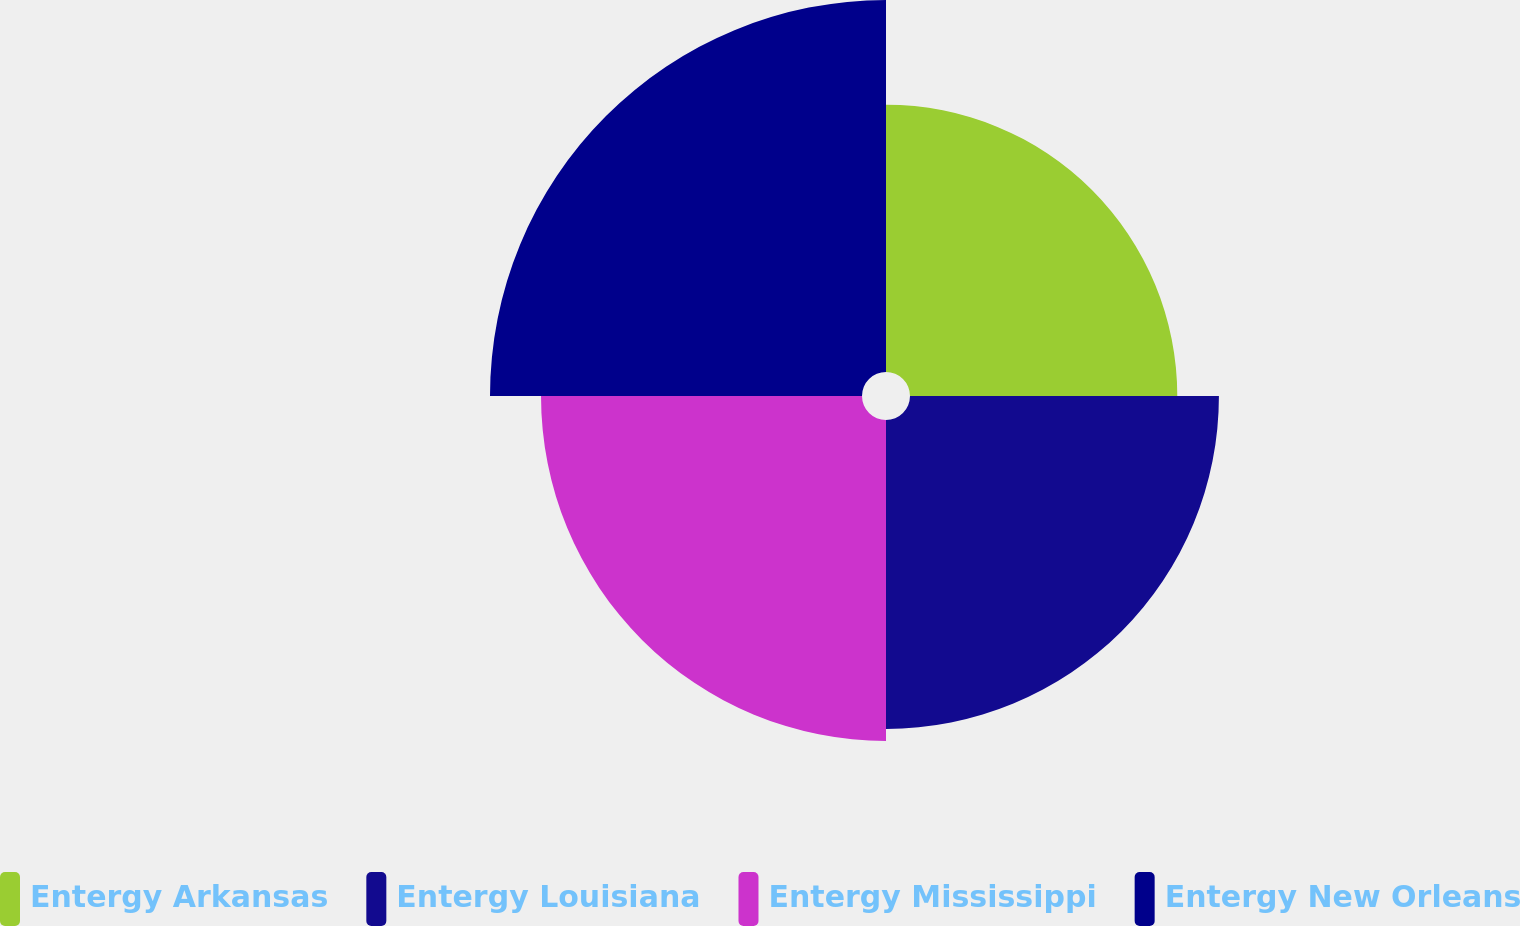Convert chart. <chart><loc_0><loc_0><loc_500><loc_500><pie_chart><fcel>Entergy Arkansas<fcel>Entergy Louisiana<fcel>Entergy Mississippi<fcel>Entergy New Orleans<nl><fcel>21.06%<fcel>24.34%<fcel>25.29%<fcel>29.31%<nl></chart> 